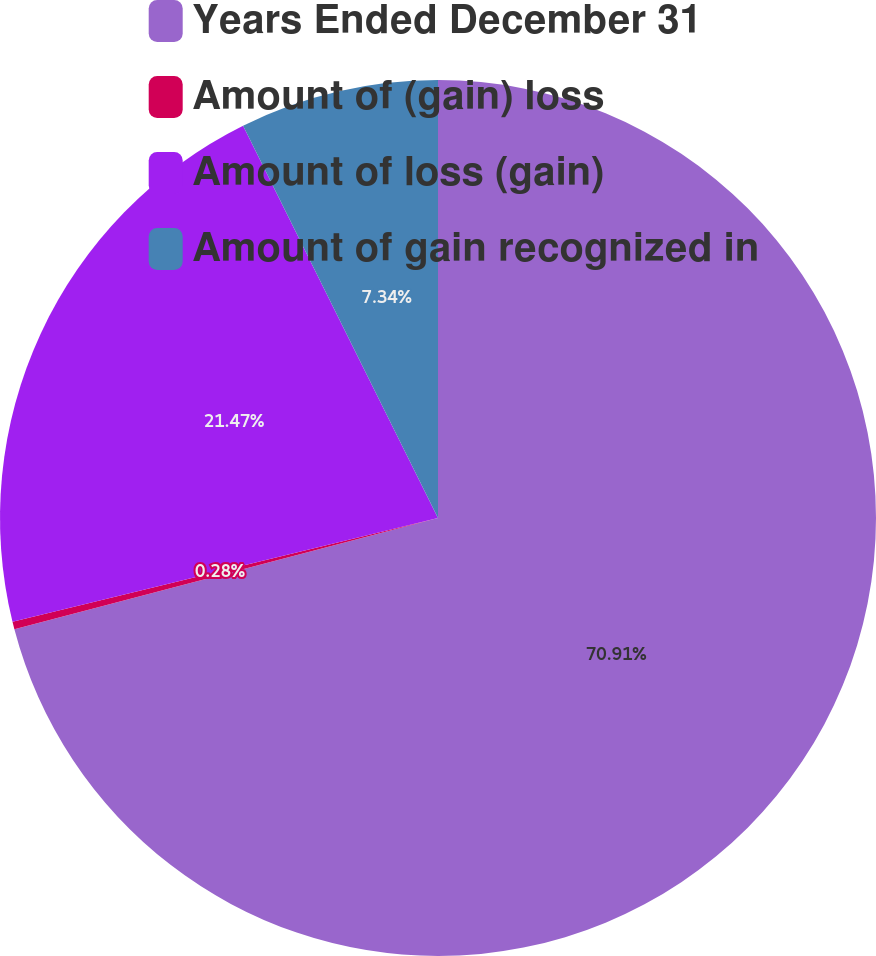<chart> <loc_0><loc_0><loc_500><loc_500><pie_chart><fcel>Years Ended December 31<fcel>Amount of (gain) loss<fcel>Amount of loss (gain)<fcel>Amount of gain recognized in<nl><fcel>70.91%<fcel>0.28%<fcel>21.47%<fcel>7.34%<nl></chart> 